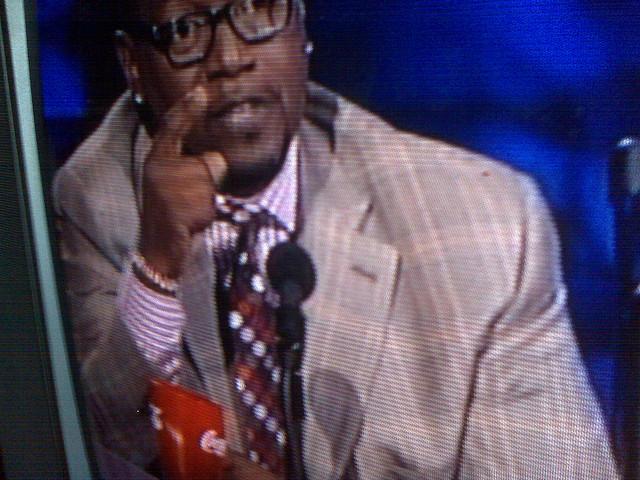How many yellow kites are in the sky?
Give a very brief answer. 0. 